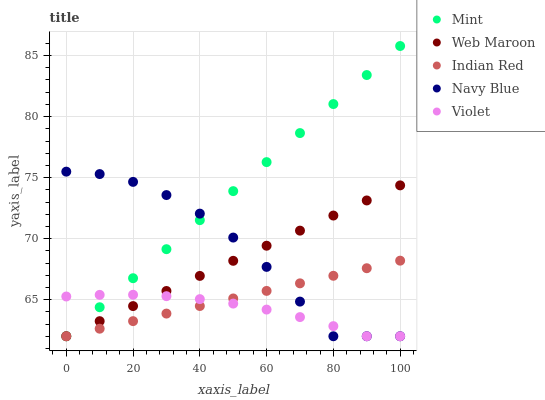Does Violet have the minimum area under the curve?
Answer yes or no. Yes. Does Mint have the maximum area under the curve?
Answer yes or no. Yes. Does Mint have the minimum area under the curve?
Answer yes or no. No. Does Violet have the maximum area under the curve?
Answer yes or no. No. Is Indian Red the smoothest?
Answer yes or no. Yes. Is Navy Blue the roughest?
Answer yes or no. Yes. Is Violet the smoothest?
Answer yes or no. No. Is Violet the roughest?
Answer yes or no. No. Does Web Maroon have the lowest value?
Answer yes or no. Yes. Does Mint have the highest value?
Answer yes or no. Yes. Does Violet have the highest value?
Answer yes or no. No. Does Navy Blue intersect Mint?
Answer yes or no. Yes. Is Navy Blue less than Mint?
Answer yes or no. No. Is Navy Blue greater than Mint?
Answer yes or no. No. 